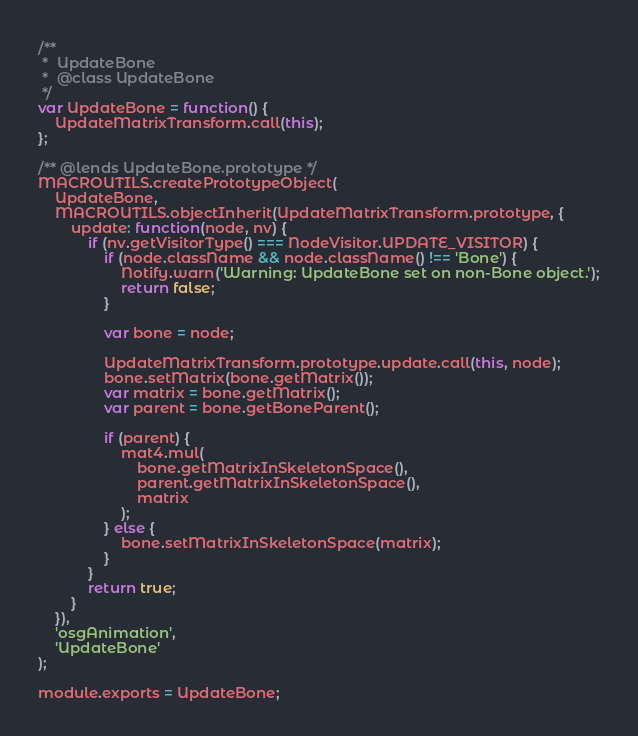<code> <loc_0><loc_0><loc_500><loc_500><_JavaScript_>/**
 *  UpdateBone
 *  @class UpdateBone
 */
var UpdateBone = function() {
    UpdateMatrixTransform.call(this);
};

/** @lends UpdateBone.prototype */
MACROUTILS.createPrototypeObject(
    UpdateBone,
    MACROUTILS.objectInherit(UpdateMatrixTransform.prototype, {
        update: function(node, nv) {
            if (nv.getVisitorType() === NodeVisitor.UPDATE_VISITOR) {
                if (node.className && node.className() !== 'Bone') {
                    Notify.warn('Warning: UpdateBone set on non-Bone object.');
                    return false;
                }

                var bone = node;

                UpdateMatrixTransform.prototype.update.call(this, node);
                bone.setMatrix(bone.getMatrix());
                var matrix = bone.getMatrix();
                var parent = bone.getBoneParent();

                if (parent) {
                    mat4.mul(
                        bone.getMatrixInSkeletonSpace(),
                        parent.getMatrixInSkeletonSpace(),
                        matrix
                    );
                } else {
                    bone.setMatrixInSkeletonSpace(matrix);
                }
            }
            return true;
        }
    }),
    'osgAnimation',
    'UpdateBone'
);

module.exports = UpdateBone;
</code> 